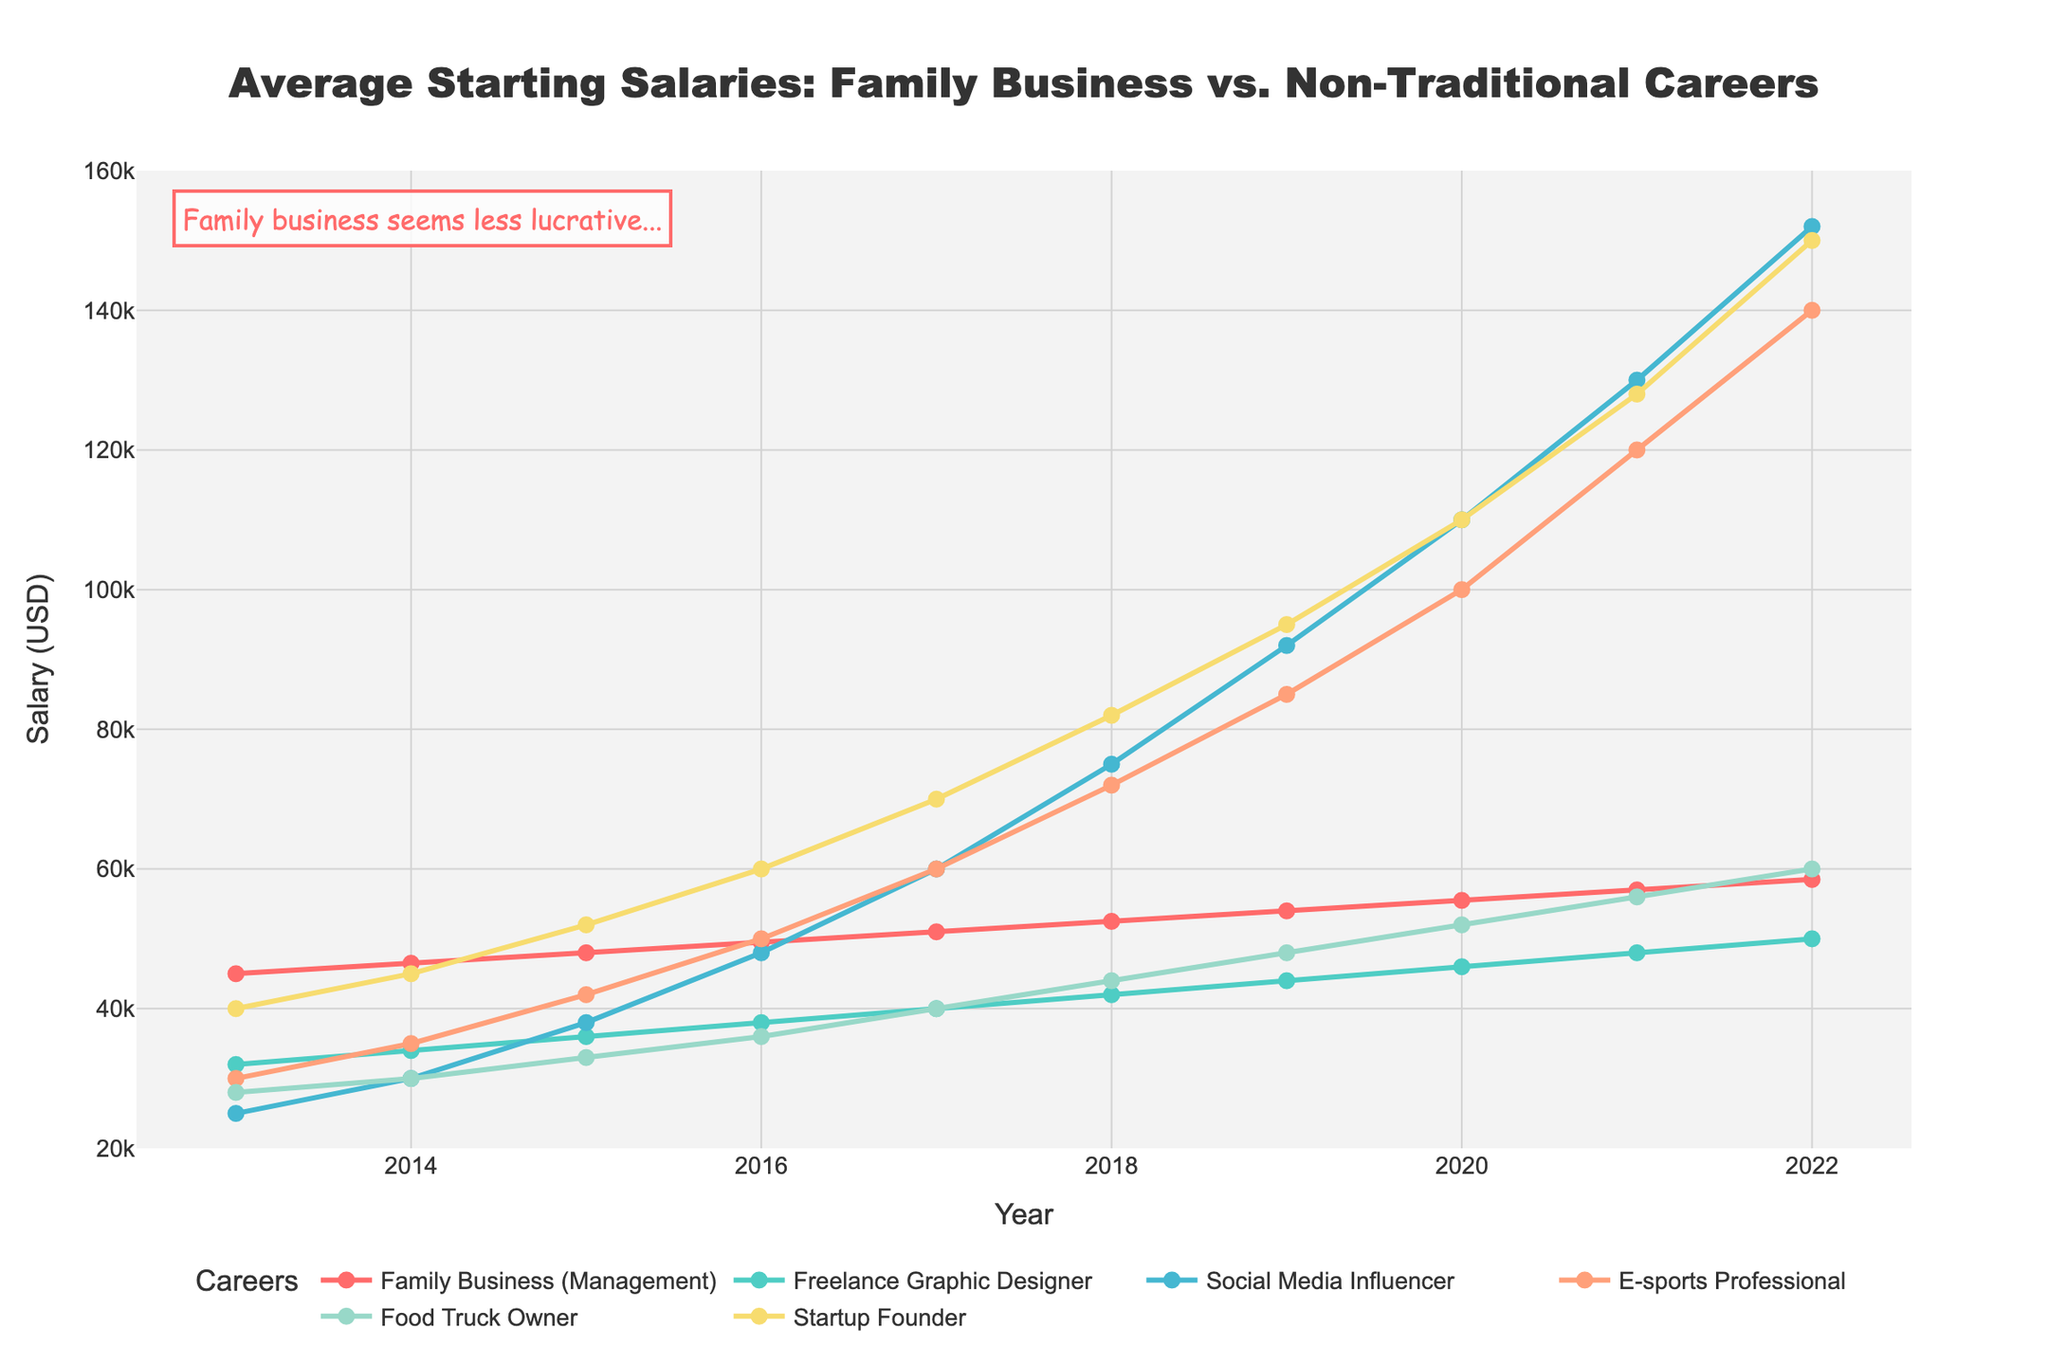What career had the highest starting salary in 2022? By looking at the year 2022, the highest salary among the careers listed is clearly Social Media Influencer with $152,000.
Answer: Social Media Influencer How did the salary for E-sports Professional change from 2013 to 2022? Find the starting salary for E-sports Professional in 2013 ($30,000) and in 2022 ($140,000). The difference is $140,000 - $30,000, which is an increase of $110,000 over the time period.
Answer: $110,000 increase Which career showed the most consistent year-on-year increase? By observing the chart, the Family Business (Management) shows a relatively straight and steady line indicating a consistent year-on-year incremental pattern, unlike others with jumps.
Answer: Family Business (Management) In 2020, which career has a higher salary: Freelance Graphic Designer or Food Truck Owner? Comparing the values for Freelance Graphic Designer ($46,000) and Food Truck Owner ($52,000) in 2020 shows that Food Truck Owner had a higher salary.
Answer: Food Truck Owner What is the average salary of a Startup Founder over the years 2015 to 2018? Sum the salaries of Startup Founder from 2015 to 2018 (52000+60000+70000+82000 = 264000) and divide by 4: 264000/4 = 66000.
Answer: $66,000 By how much did the Social Media Influencer salary increase from 2019 to 2022? The Social Media Influencer salary in 2019 was $92,000 and in 2022 was $152,000. The increase can be calculated as $152,000 - $92,000 = $60,000.
Answer: $60,000 In which year did the average starting salary of Freelance Graphic Designer reach $40,000? Observing the plot, the Freelance Graphic Designer starting salary reached $40,000 in 2017.
Answer: 2017 What is the range of salaries for the Family Business from 2013 to 2022? The lowest salary for Family Business (Management) is $45,000 in 2013, and the highest is $58,500 in 2022. The range is $58,500 - $45,000 = $13,500.
Answer: $13,500 What trend can be observed in the starting salary of Social Media Influencers over the years? The starting salary for Social Media Influencers shows a rapidly increasing trend, with steep rises each year, especially from 2015 onwards where it escalates significantly.
Answer: Rapidly increasing trend Comparing Startup Founder and Family Business roles, which saw a higher absolute increase in starting salaries from 2013 to 2022? Startup Founder's salary in 2013 was $40,000 and in 2022 was $150,000, an increase of $110,000. Family Business went from $45,000 to $58,500 in the same period, an increase of $13,500. Clearly, Startup Founder saw a higher absolute increase.
Answer: Startup Founder 